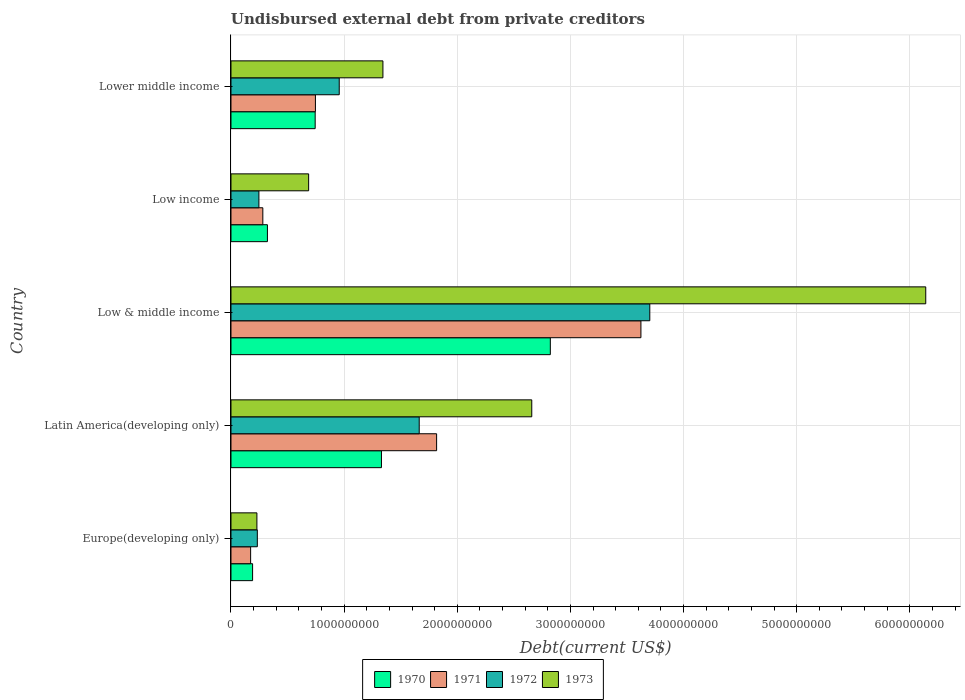How many groups of bars are there?
Offer a very short reply. 5. Are the number of bars on each tick of the Y-axis equal?
Offer a terse response. Yes. How many bars are there on the 1st tick from the bottom?
Your response must be concise. 4. What is the label of the 1st group of bars from the top?
Provide a short and direct response. Lower middle income. In how many cases, is the number of bars for a given country not equal to the number of legend labels?
Make the answer very short. 0. What is the total debt in 1971 in Latin America(developing only)?
Make the answer very short. 1.82e+09. Across all countries, what is the maximum total debt in 1973?
Your answer should be very brief. 6.14e+09. Across all countries, what is the minimum total debt in 1970?
Your answer should be compact. 1.91e+08. In which country was the total debt in 1970 minimum?
Make the answer very short. Europe(developing only). What is the total total debt in 1973 in the graph?
Your response must be concise. 1.11e+1. What is the difference between the total debt in 1972 in Low & middle income and that in Low income?
Keep it short and to the point. 3.45e+09. What is the difference between the total debt in 1972 in Latin America(developing only) and the total debt in 1973 in Low & middle income?
Your answer should be compact. -4.48e+09. What is the average total debt in 1973 per country?
Provide a succinct answer. 2.21e+09. What is the difference between the total debt in 1970 and total debt in 1973 in Latin America(developing only)?
Provide a short and direct response. -1.33e+09. What is the ratio of the total debt in 1971 in Latin America(developing only) to that in Lower middle income?
Offer a very short reply. 2.44. Is the total debt in 1972 in Europe(developing only) less than that in Low income?
Provide a short and direct response. Yes. Is the difference between the total debt in 1970 in Latin America(developing only) and Low & middle income greater than the difference between the total debt in 1973 in Latin America(developing only) and Low & middle income?
Offer a very short reply. Yes. What is the difference between the highest and the second highest total debt in 1970?
Provide a succinct answer. 1.49e+09. What is the difference between the highest and the lowest total debt in 1972?
Your answer should be compact. 3.47e+09. Is it the case that in every country, the sum of the total debt in 1971 and total debt in 1973 is greater than the sum of total debt in 1972 and total debt in 1970?
Offer a very short reply. No. What does the 2nd bar from the bottom in Low & middle income represents?
Ensure brevity in your answer.  1971. Is it the case that in every country, the sum of the total debt in 1970 and total debt in 1972 is greater than the total debt in 1971?
Ensure brevity in your answer.  Yes. Are all the bars in the graph horizontal?
Your response must be concise. Yes. What is the difference between two consecutive major ticks on the X-axis?
Your response must be concise. 1.00e+09. Are the values on the major ticks of X-axis written in scientific E-notation?
Offer a terse response. No. Does the graph contain grids?
Offer a terse response. Yes. Where does the legend appear in the graph?
Give a very brief answer. Bottom center. How are the legend labels stacked?
Provide a succinct answer. Horizontal. What is the title of the graph?
Provide a short and direct response. Undisbursed external debt from private creditors. Does "2007" appear as one of the legend labels in the graph?
Your response must be concise. No. What is the label or title of the X-axis?
Provide a short and direct response. Debt(current US$). What is the Debt(current US$) in 1970 in Europe(developing only)?
Your answer should be compact. 1.91e+08. What is the Debt(current US$) in 1971 in Europe(developing only)?
Provide a succinct answer. 1.74e+08. What is the Debt(current US$) of 1972 in Europe(developing only)?
Ensure brevity in your answer.  2.33e+08. What is the Debt(current US$) of 1973 in Europe(developing only)?
Your answer should be compact. 2.29e+08. What is the Debt(current US$) of 1970 in Latin America(developing only)?
Ensure brevity in your answer.  1.33e+09. What is the Debt(current US$) of 1971 in Latin America(developing only)?
Ensure brevity in your answer.  1.82e+09. What is the Debt(current US$) of 1972 in Latin America(developing only)?
Keep it short and to the point. 1.66e+09. What is the Debt(current US$) of 1973 in Latin America(developing only)?
Make the answer very short. 2.66e+09. What is the Debt(current US$) of 1970 in Low & middle income?
Provide a short and direct response. 2.82e+09. What is the Debt(current US$) of 1971 in Low & middle income?
Offer a terse response. 3.62e+09. What is the Debt(current US$) in 1972 in Low & middle income?
Provide a short and direct response. 3.70e+09. What is the Debt(current US$) in 1973 in Low & middle income?
Your answer should be compact. 6.14e+09. What is the Debt(current US$) in 1970 in Low income?
Provide a succinct answer. 3.22e+08. What is the Debt(current US$) in 1971 in Low income?
Offer a terse response. 2.82e+08. What is the Debt(current US$) of 1972 in Low income?
Provide a succinct answer. 2.47e+08. What is the Debt(current US$) of 1973 in Low income?
Make the answer very short. 6.86e+08. What is the Debt(current US$) in 1970 in Lower middle income?
Your answer should be very brief. 7.44e+08. What is the Debt(current US$) in 1971 in Lower middle income?
Your answer should be very brief. 7.46e+08. What is the Debt(current US$) of 1972 in Lower middle income?
Offer a terse response. 9.57e+08. What is the Debt(current US$) in 1973 in Lower middle income?
Make the answer very short. 1.34e+09. Across all countries, what is the maximum Debt(current US$) in 1970?
Give a very brief answer. 2.82e+09. Across all countries, what is the maximum Debt(current US$) in 1971?
Make the answer very short. 3.62e+09. Across all countries, what is the maximum Debt(current US$) in 1972?
Your answer should be very brief. 3.70e+09. Across all countries, what is the maximum Debt(current US$) in 1973?
Give a very brief answer. 6.14e+09. Across all countries, what is the minimum Debt(current US$) of 1970?
Your answer should be compact. 1.91e+08. Across all countries, what is the minimum Debt(current US$) of 1971?
Make the answer very short. 1.74e+08. Across all countries, what is the minimum Debt(current US$) in 1972?
Give a very brief answer. 2.33e+08. Across all countries, what is the minimum Debt(current US$) of 1973?
Give a very brief answer. 2.29e+08. What is the total Debt(current US$) in 1970 in the graph?
Give a very brief answer. 5.41e+09. What is the total Debt(current US$) of 1971 in the graph?
Your answer should be compact. 6.64e+09. What is the total Debt(current US$) of 1972 in the graph?
Your response must be concise. 6.80e+09. What is the total Debt(current US$) in 1973 in the graph?
Give a very brief answer. 1.11e+1. What is the difference between the Debt(current US$) of 1970 in Europe(developing only) and that in Latin America(developing only)?
Provide a short and direct response. -1.14e+09. What is the difference between the Debt(current US$) in 1971 in Europe(developing only) and that in Latin America(developing only)?
Provide a short and direct response. -1.64e+09. What is the difference between the Debt(current US$) in 1972 in Europe(developing only) and that in Latin America(developing only)?
Provide a short and direct response. -1.43e+09. What is the difference between the Debt(current US$) of 1973 in Europe(developing only) and that in Latin America(developing only)?
Offer a terse response. -2.43e+09. What is the difference between the Debt(current US$) of 1970 in Europe(developing only) and that in Low & middle income?
Make the answer very short. -2.63e+09. What is the difference between the Debt(current US$) in 1971 in Europe(developing only) and that in Low & middle income?
Give a very brief answer. -3.45e+09. What is the difference between the Debt(current US$) in 1972 in Europe(developing only) and that in Low & middle income?
Make the answer very short. -3.47e+09. What is the difference between the Debt(current US$) of 1973 in Europe(developing only) and that in Low & middle income?
Your response must be concise. -5.91e+09. What is the difference between the Debt(current US$) of 1970 in Europe(developing only) and that in Low income?
Make the answer very short. -1.31e+08. What is the difference between the Debt(current US$) in 1971 in Europe(developing only) and that in Low income?
Ensure brevity in your answer.  -1.08e+08. What is the difference between the Debt(current US$) in 1972 in Europe(developing only) and that in Low income?
Your response must be concise. -1.39e+07. What is the difference between the Debt(current US$) in 1973 in Europe(developing only) and that in Low income?
Your answer should be compact. -4.57e+08. What is the difference between the Debt(current US$) of 1970 in Europe(developing only) and that in Lower middle income?
Your answer should be compact. -5.53e+08. What is the difference between the Debt(current US$) in 1971 in Europe(developing only) and that in Lower middle income?
Offer a terse response. -5.73e+08. What is the difference between the Debt(current US$) in 1972 in Europe(developing only) and that in Lower middle income?
Ensure brevity in your answer.  -7.24e+08. What is the difference between the Debt(current US$) of 1973 in Europe(developing only) and that in Lower middle income?
Provide a short and direct response. -1.11e+09. What is the difference between the Debt(current US$) of 1970 in Latin America(developing only) and that in Low & middle income?
Make the answer very short. -1.49e+09. What is the difference between the Debt(current US$) of 1971 in Latin America(developing only) and that in Low & middle income?
Your answer should be compact. -1.81e+09. What is the difference between the Debt(current US$) of 1972 in Latin America(developing only) and that in Low & middle income?
Give a very brief answer. -2.04e+09. What is the difference between the Debt(current US$) of 1973 in Latin America(developing only) and that in Low & middle income?
Provide a short and direct response. -3.48e+09. What is the difference between the Debt(current US$) in 1970 in Latin America(developing only) and that in Low income?
Make the answer very short. 1.01e+09. What is the difference between the Debt(current US$) in 1971 in Latin America(developing only) and that in Low income?
Provide a short and direct response. 1.54e+09. What is the difference between the Debt(current US$) of 1972 in Latin America(developing only) and that in Low income?
Make the answer very short. 1.42e+09. What is the difference between the Debt(current US$) in 1973 in Latin America(developing only) and that in Low income?
Your answer should be compact. 1.97e+09. What is the difference between the Debt(current US$) in 1970 in Latin America(developing only) and that in Lower middle income?
Ensure brevity in your answer.  5.86e+08. What is the difference between the Debt(current US$) of 1971 in Latin America(developing only) and that in Lower middle income?
Provide a succinct answer. 1.07e+09. What is the difference between the Debt(current US$) of 1972 in Latin America(developing only) and that in Lower middle income?
Provide a succinct answer. 7.07e+08. What is the difference between the Debt(current US$) in 1973 in Latin America(developing only) and that in Lower middle income?
Provide a short and direct response. 1.32e+09. What is the difference between the Debt(current US$) of 1970 in Low & middle income and that in Low income?
Your answer should be very brief. 2.50e+09. What is the difference between the Debt(current US$) in 1971 in Low & middle income and that in Low income?
Offer a very short reply. 3.34e+09. What is the difference between the Debt(current US$) of 1972 in Low & middle income and that in Low income?
Offer a very short reply. 3.45e+09. What is the difference between the Debt(current US$) in 1973 in Low & middle income and that in Low income?
Provide a succinct answer. 5.45e+09. What is the difference between the Debt(current US$) of 1970 in Low & middle income and that in Lower middle income?
Offer a very short reply. 2.08e+09. What is the difference between the Debt(current US$) in 1971 in Low & middle income and that in Lower middle income?
Give a very brief answer. 2.88e+09. What is the difference between the Debt(current US$) in 1972 in Low & middle income and that in Lower middle income?
Provide a succinct answer. 2.74e+09. What is the difference between the Debt(current US$) in 1973 in Low & middle income and that in Lower middle income?
Your response must be concise. 4.80e+09. What is the difference between the Debt(current US$) of 1970 in Low income and that in Lower middle income?
Ensure brevity in your answer.  -4.22e+08. What is the difference between the Debt(current US$) of 1971 in Low income and that in Lower middle income?
Offer a very short reply. -4.65e+08. What is the difference between the Debt(current US$) of 1972 in Low income and that in Lower middle income?
Your answer should be very brief. -7.10e+08. What is the difference between the Debt(current US$) of 1973 in Low income and that in Lower middle income?
Provide a succinct answer. -6.56e+08. What is the difference between the Debt(current US$) in 1970 in Europe(developing only) and the Debt(current US$) in 1971 in Latin America(developing only)?
Your response must be concise. -1.63e+09. What is the difference between the Debt(current US$) of 1970 in Europe(developing only) and the Debt(current US$) of 1972 in Latin America(developing only)?
Ensure brevity in your answer.  -1.47e+09. What is the difference between the Debt(current US$) of 1970 in Europe(developing only) and the Debt(current US$) of 1973 in Latin America(developing only)?
Ensure brevity in your answer.  -2.47e+09. What is the difference between the Debt(current US$) of 1971 in Europe(developing only) and the Debt(current US$) of 1972 in Latin America(developing only)?
Provide a succinct answer. -1.49e+09. What is the difference between the Debt(current US$) in 1971 in Europe(developing only) and the Debt(current US$) in 1973 in Latin America(developing only)?
Offer a very short reply. -2.48e+09. What is the difference between the Debt(current US$) in 1972 in Europe(developing only) and the Debt(current US$) in 1973 in Latin America(developing only)?
Offer a very short reply. -2.43e+09. What is the difference between the Debt(current US$) in 1970 in Europe(developing only) and the Debt(current US$) in 1971 in Low & middle income?
Ensure brevity in your answer.  -3.43e+09. What is the difference between the Debt(current US$) of 1970 in Europe(developing only) and the Debt(current US$) of 1972 in Low & middle income?
Provide a short and direct response. -3.51e+09. What is the difference between the Debt(current US$) of 1970 in Europe(developing only) and the Debt(current US$) of 1973 in Low & middle income?
Your response must be concise. -5.95e+09. What is the difference between the Debt(current US$) in 1971 in Europe(developing only) and the Debt(current US$) in 1972 in Low & middle income?
Provide a succinct answer. -3.53e+09. What is the difference between the Debt(current US$) of 1971 in Europe(developing only) and the Debt(current US$) of 1973 in Low & middle income?
Your answer should be compact. -5.97e+09. What is the difference between the Debt(current US$) of 1972 in Europe(developing only) and the Debt(current US$) of 1973 in Low & middle income?
Your response must be concise. -5.91e+09. What is the difference between the Debt(current US$) of 1970 in Europe(developing only) and the Debt(current US$) of 1971 in Low income?
Offer a terse response. -9.05e+07. What is the difference between the Debt(current US$) in 1970 in Europe(developing only) and the Debt(current US$) in 1972 in Low income?
Give a very brief answer. -5.58e+07. What is the difference between the Debt(current US$) in 1970 in Europe(developing only) and the Debt(current US$) in 1973 in Low income?
Make the answer very short. -4.95e+08. What is the difference between the Debt(current US$) in 1971 in Europe(developing only) and the Debt(current US$) in 1972 in Low income?
Your response must be concise. -7.31e+07. What is the difference between the Debt(current US$) of 1971 in Europe(developing only) and the Debt(current US$) of 1973 in Low income?
Give a very brief answer. -5.13e+08. What is the difference between the Debt(current US$) of 1972 in Europe(developing only) and the Debt(current US$) of 1973 in Low income?
Ensure brevity in your answer.  -4.54e+08. What is the difference between the Debt(current US$) of 1970 in Europe(developing only) and the Debt(current US$) of 1971 in Lower middle income?
Keep it short and to the point. -5.55e+08. What is the difference between the Debt(current US$) in 1970 in Europe(developing only) and the Debt(current US$) in 1972 in Lower middle income?
Keep it short and to the point. -7.66e+08. What is the difference between the Debt(current US$) in 1970 in Europe(developing only) and the Debt(current US$) in 1973 in Lower middle income?
Provide a succinct answer. -1.15e+09. What is the difference between the Debt(current US$) of 1971 in Europe(developing only) and the Debt(current US$) of 1972 in Lower middle income?
Provide a short and direct response. -7.83e+08. What is the difference between the Debt(current US$) of 1971 in Europe(developing only) and the Debt(current US$) of 1973 in Lower middle income?
Keep it short and to the point. -1.17e+09. What is the difference between the Debt(current US$) of 1972 in Europe(developing only) and the Debt(current US$) of 1973 in Lower middle income?
Give a very brief answer. -1.11e+09. What is the difference between the Debt(current US$) in 1970 in Latin America(developing only) and the Debt(current US$) in 1971 in Low & middle income?
Provide a succinct answer. -2.29e+09. What is the difference between the Debt(current US$) of 1970 in Latin America(developing only) and the Debt(current US$) of 1972 in Low & middle income?
Your response must be concise. -2.37e+09. What is the difference between the Debt(current US$) in 1970 in Latin America(developing only) and the Debt(current US$) in 1973 in Low & middle income?
Your answer should be compact. -4.81e+09. What is the difference between the Debt(current US$) of 1971 in Latin America(developing only) and the Debt(current US$) of 1972 in Low & middle income?
Give a very brief answer. -1.88e+09. What is the difference between the Debt(current US$) in 1971 in Latin America(developing only) and the Debt(current US$) in 1973 in Low & middle income?
Provide a short and direct response. -4.32e+09. What is the difference between the Debt(current US$) of 1972 in Latin America(developing only) and the Debt(current US$) of 1973 in Low & middle income?
Offer a terse response. -4.48e+09. What is the difference between the Debt(current US$) in 1970 in Latin America(developing only) and the Debt(current US$) in 1971 in Low income?
Your answer should be compact. 1.05e+09. What is the difference between the Debt(current US$) of 1970 in Latin America(developing only) and the Debt(current US$) of 1972 in Low income?
Provide a short and direct response. 1.08e+09. What is the difference between the Debt(current US$) in 1970 in Latin America(developing only) and the Debt(current US$) in 1973 in Low income?
Provide a succinct answer. 6.43e+08. What is the difference between the Debt(current US$) of 1971 in Latin America(developing only) and the Debt(current US$) of 1972 in Low income?
Offer a terse response. 1.57e+09. What is the difference between the Debt(current US$) in 1971 in Latin America(developing only) and the Debt(current US$) in 1973 in Low income?
Give a very brief answer. 1.13e+09. What is the difference between the Debt(current US$) of 1972 in Latin America(developing only) and the Debt(current US$) of 1973 in Low income?
Provide a succinct answer. 9.77e+08. What is the difference between the Debt(current US$) in 1970 in Latin America(developing only) and the Debt(current US$) in 1971 in Lower middle income?
Ensure brevity in your answer.  5.84e+08. What is the difference between the Debt(current US$) of 1970 in Latin America(developing only) and the Debt(current US$) of 1972 in Lower middle income?
Your answer should be very brief. 3.73e+08. What is the difference between the Debt(current US$) of 1970 in Latin America(developing only) and the Debt(current US$) of 1973 in Lower middle income?
Give a very brief answer. -1.29e+07. What is the difference between the Debt(current US$) of 1971 in Latin America(developing only) and the Debt(current US$) of 1972 in Lower middle income?
Provide a short and direct response. 8.61e+08. What is the difference between the Debt(current US$) in 1971 in Latin America(developing only) and the Debt(current US$) in 1973 in Lower middle income?
Provide a short and direct response. 4.75e+08. What is the difference between the Debt(current US$) in 1972 in Latin America(developing only) and the Debt(current US$) in 1973 in Lower middle income?
Your answer should be compact. 3.21e+08. What is the difference between the Debt(current US$) in 1970 in Low & middle income and the Debt(current US$) in 1971 in Low income?
Your answer should be very brief. 2.54e+09. What is the difference between the Debt(current US$) in 1970 in Low & middle income and the Debt(current US$) in 1972 in Low income?
Your answer should be very brief. 2.58e+09. What is the difference between the Debt(current US$) in 1970 in Low & middle income and the Debt(current US$) in 1973 in Low income?
Give a very brief answer. 2.14e+09. What is the difference between the Debt(current US$) in 1971 in Low & middle income and the Debt(current US$) in 1972 in Low income?
Your response must be concise. 3.38e+09. What is the difference between the Debt(current US$) in 1971 in Low & middle income and the Debt(current US$) in 1973 in Low income?
Your response must be concise. 2.94e+09. What is the difference between the Debt(current US$) of 1972 in Low & middle income and the Debt(current US$) of 1973 in Low income?
Provide a succinct answer. 3.02e+09. What is the difference between the Debt(current US$) of 1970 in Low & middle income and the Debt(current US$) of 1971 in Lower middle income?
Your response must be concise. 2.08e+09. What is the difference between the Debt(current US$) in 1970 in Low & middle income and the Debt(current US$) in 1972 in Lower middle income?
Provide a short and direct response. 1.87e+09. What is the difference between the Debt(current US$) of 1970 in Low & middle income and the Debt(current US$) of 1973 in Lower middle income?
Ensure brevity in your answer.  1.48e+09. What is the difference between the Debt(current US$) in 1971 in Low & middle income and the Debt(current US$) in 1972 in Lower middle income?
Keep it short and to the point. 2.67e+09. What is the difference between the Debt(current US$) in 1971 in Low & middle income and the Debt(current US$) in 1973 in Lower middle income?
Provide a succinct answer. 2.28e+09. What is the difference between the Debt(current US$) of 1972 in Low & middle income and the Debt(current US$) of 1973 in Lower middle income?
Your answer should be compact. 2.36e+09. What is the difference between the Debt(current US$) in 1970 in Low income and the Debt(current US$) in 1971 in Lower middle income?
Provide a short and direct response. -4.24e+08. What is the difference between the Debt(current US$) in 1970 in Low income and the Debt(current US$) in 1972 in Lower middle income?
Your answer should be very brief. -6.35e+08. What is the difference between the Debt(current US$) of 1970 in Low income and the Debt(current US$) of 1973 in Lower middle income?
Ensure brevity in your answer.  -1.02e+09. What is the difference between the Debt(current US$) of 1971 in Low income and the Debt(current US$) of 1972 in Lower middle income?
Provide a short and direct response. -6.75e+08. What is the difference between the Debt(current US$) of 1971 in Low income and the Debt(current US$) of 1973 in Lower middle income?
Your response must be concise. -1.06e+09. What is the difference between the Debt(current US$) of 1972 in Low income and the Debt(current US$) of 1973 in Lower middle income?
Make the answer very short. -1.10e+09. What is the average Debt(current US$) in 1970 per country?
Provide a succinct answer. 1.08e+09. What is the average Debt(current US$) in 1971 per country?
Provide a short and direct response. 1.33e+09. What is the average Debt(current US$) of 1972 per country?
Provide a succinct answer. 1.36e+09. What is the average Debt(current US$) in 1973 per country?
Your answer should be compact. 2.21e+09. What is the difference between the Debt(current US$) in 1970 and Debt(current US$) in 1971 in Europe(developing only)?
Make the answer very short. 1.74e+07. What is the difference between the Debt(current US$) of 1970 and Debt(current US$) of 1972 in Europe(developing only)?
Offer a terse response. -4.19e+07. What is the difference between the Debt(current US$) of 1970 and Debt(current US$) of 1973 in Europe(developing only)?
Your response must be concise. -3.81e+07. What is the difference between the Debt(current US$) of 1971 and Debt(current US$) of 1972 in Europe(developing only)?
Offer a terse response. -5.92e+07. What is the difference between the Debt(current US$) of 1971 and Debt(current US$) of 1973 in Europe(developing only)?
Offer a terse response. -5.55e+07. What is the difference between the Debt(current US$) in 1972 and Debt(current US$) in 1973 in Europe(developing only)?
Your response must be concise. 3.73e+06. What is the difference between the Debt(current US$) of 1970 and Debt(current US$) of 1971 in Latin America(developing only)?
Provide a succinct answer. -4.88e+08. What is the difference between the Debt(current US$) in 1970 and Debt(current US$) in 1972 in Latin America(developing only)?
Provide a succinct answer. -3.34e+08. What is the difference between the Debt(current US$) in 1970 and Debt(current US$) in 1973 in Latin America(developing only)?
Make the answer very short. -1.33e+09. What is the difference between the Debt(current US$) of 1971 and Debt(current US$) of 1972 in Latin America(developing only)?
Make the answer very short. 1.54e+08. What is the difference between the Debt(current US$) of 1971 and Debt(current US$) of 1973 in Latin America(developing only)?
Offer a very short reply. -8.41e+08. What is the difference between the Debt(current US$) of 1972 and Debt(current US$) of 1973 in Latin America(developing only)?
Give a very brief answer. -9.95e+08. What is the difference between the Debt(current US$) of 1970 and Debt(current US$) of 1971 in Low & middle income?
Your answer should be compact. -8.01e+08. What is the difference between the Debt(current US$) in 1970 and Debt(current US$) in 1972 in Low & middle income?
Give a very brief answer. -8.79e+08. What is the difference between the Debt(current US$) in 1970 and Debt(current US$) in 1973 in Low & middle income?
Ensure brevity in your answer.  -3.32e+09. What is the difference between the Debt(current US$) of 1971 and Debt(current US$) of 1972 in Low & middle income?
Make the answer very short. -7.84e+07. What is the difference between the Debt(current US$) of 1971 and Debt(current US$) of 1973 in Low & middle income?
Provide a short and direct response. -2.52e+09. What is the difference between the Debt(current US$) in 1972 and Debt(current US$) in 1973 in Low & middle income?
Your response must be concise. -2.44e+09. What is the difference between the Debt(current US$) in 1970 and Debt(current US$) in 1971 in Low income?
Provide a succinct answer. 4.06e+07. What is the difference between the Debt(current US$) in 1970 and Debt(current US$) in 1972 in Low income?
Keep it short and to the point. 7.53e+07. What is the difference between the Debt(current US$) in 1970 and Debt(current US$) in 1973 in Low income?
Make the answer very short. -3.64e+08. What is the difference between the Debt(current US$) of 1971 and Debt(current US$) of 1972 in Low income?
Provide a succinct answer. 3.47e+07. What is the difference between the Debt(current US$) of 1971 and Debt(current US$) of 1973 in Low income?
Your answer should be compact. -4.05e+08. What is the difference between the Debt(current US$) of 1972 and Debt(current US$) of 1973 in Low income?
Ensure brevity in your answer.  -4.40e+08. What is the difference between the Debt(current US$) in 1970 and Debt(current US$) in 1971 in Lower middle income?
Offer a very short reply. -2.10e+06. What is the difference between the Debt(current US$) in 1970 and Debt(current US$) in 1972 in Lower middle income?
Provide a succinct answer. -2.13e+08. What is the difference between the Debt(current US$) of 1970 and Debt(current US$) of 1973 in Lower middle income?
Your answer should be very brief. -5.99e+08. What is the difference between the Debt(current US$) of 1971 and Debt(current US$) of 1972 in Lower middle income?
Offer a very short reply. -2.11e+08. What is the difference between the Debt(current US$) of 1971 and Debt(current US$) of 1973 in Lower middle income?
Provide a short and direct response. -5.97e+08. What is the difference between the Debt(current US$) in 1972 and Debt(current US$) in 1973 in Lower middle income?
Give a very brief answer. -3.86e+08. What is the ratio of the Debt(current US$) of 1970 in Europe(developing only) to that in Latin America(developing only)?
Your response must be concise. 0.14. What is the ratio of the Debt(current US$) in 1971 in Europe(developing only) to that in Latin America(developing only)?
Give a very brief answer. 0.1. What is the ratio of the Debt(current US$) of 1972 in Europe(developing only) to that in Latin America(developing only)?
Give a very brief answer. 0.14. What is the ratio of the Debt(current US$) in 1973 in Europe(developing only) to that in Latin America(developing only)?
Ensure brevity in your answer.  0.09. What is the ratio of the Debt(current US$) of 1970 in Europe(developing only) to that in Low & middle income?
Your answer should be compact. 0.07. What is the ratio of the Debt(current US$) of 1971 in Europe(developing only) to that in Low & middle income?
Your answer should be compact. 0.05. What is the ratio of the Debt(current US$) in 1972 in Europe(developing only) to that in Low & middle income?
Provide a succinct answer. 0.06. What is the ratio of the Debt(current US$) in 1973 in Europe(developing only) to that in Low & middle income?
Offer a terse response. 0.04. What is the ratio of the Debt(current US$) of 1970 in Europe(developing only) to that in Low income?
Your answer should be very brief. 0.59. What is the ratio of the Debt(current US$) of 1971 in Europe(developing only) to that in Low income?
Your response must be concise. 0.62. What is the ratio of the Debt(current US$) of 1972 in Europe(developing only) to that in Low income?
Give a very brief answer. 0.94. What is the ratio of the Debt(current US$) in 1973 in Europe(developing only) to that in Low income?
Your answer should be compact. 0.33. What is the ratio of the Debt(current US$) of 1970 in Europe(developing only) to that in Lower middle income?
Make the answer very short. 0.26. What is the ratio of the Debt(current US$) of 1971 in Europe(developing only) to that in Lower middle income?
Ensure brevity in your answer.  0.23. What is the ratio of the Debt(current US$) in 1972 in Europe(developing only) to that in Lower middle income?
Your answer should be very brief. 0.24. What is the ratio of the Debt(current US$) of 1973 in Europe(developing only) to that in Lower middle income?
Make the answer very short. 0.17. What is the ratio of the Debt(current US$) in 1970 in Latin America(developing only) to that in Low & middle income?
Ensure brevity in your answer.  0.47. What is the ratio of the Debt(current US$) of 1971 in Latin America(developing only) to that in Low & middle income?
Give a very brief answer. 0.5. What is the ratio of the Debt(current US$) of 1972 in Latin America(developing only) to that in Low & middle income?
Ensure brevity in your answer.  0.45. What is the ratio of the Debt(current US$) of 1973 in Latin America(developing only) to that in Low & middle income?
Offer a very short reply. 0.43. What is the ratio of the Debt(current US$) of 1970 in Latin America(developing only) to that in Low income?
Make the answer very short. 4.13. What is the ratio of the Debt(current US$) of 1971 in Latin America(developing only) to that in Low income?
Make the answer very short. 6.46. What is the ratio of the Debt(current US$) in 1972 in Latin America(developing only) to that in Low income?
Provide a succinct answer. 6.74. What is the ratio of the Debt(current US$) in 1973 in Latin America(developing only) to that in Low income?
Your answer should be compact. 3.87. What is the ratio of the Debt(current US$) in 1970 in Latin America(developing only) to that in Lower middle income?
Provide a short and direct response. 1.79. What is the ratio of the Debt(current US$) in 1971 in Latin America(developing only) to that in Lower middle income?
Ensure brevity in your answer.  2.44. What is the ratio of the Debt(current US$) of 1972 in Latin America(developing only) to that in Lower middle income?
Make the answer very short. 1.74. What is the ratio of the Debt(current US$) of 1973 in Latin America(developing only) to that in Lower middle income?
Make the answer very short. 1.98. What is the ratio of the Debt(current US$) in 1970 in Low & middle income to that in Low income?
Your answer should be very brief. 8.76. What is the ratio of the Debt(current US$) of 1971 in Low & middle income to that in Low income?
Give a very brief answer. 12.87. What is the ratio of the Debt(current US$) in 1972 in Low & middle income to that in Low income?
Offer a terse response. 15. What is the ratio of the Debt(current US$) in 1973 in Low & middle income to that in Low income?
Ensure brevity in your answer.  8.95. What is the ratio of the Debt(current US$) of 1970 in Low & middle income to that in Lower middle income?
Offer a terse response. 3.79. What is the ratio of the Debt(current US$) of 1971 in Low & middle income to that in Lower middle income?
Offer a very short reply. 4.86. What is the ratio of the Debt(current US$) in 1972 in Low & middle income to that in Lower middle income?
Ensure brevity in your answer.  3.87. What is the ratio of the Debt(current US$) of 1973 in Low & middle income to that in Lower middle income?
Give a very brief answer. 4.57. What is the ratio of the Debt(current US$) in 1970 in Low income to that in Lower middle income?
Provide a short and direct response. 0.43. What is the ratio of the Debt(current US$) in 1971 in Low income to that in Lower middle income?
Give a very brief answer. 0.38. What is the ratio of the Debt(current US$) of 1972 in Low income to that in Lower middle income?
Your answer should be compact. 0.26. What is the ratio of the Debt(current US$) of 1973 in Low income to that in Lower middle income?
Keep it short and to the point. 0.51. What is the difference between the highest and the second highest Debt(current US$) in 1970?
Ensure brevity in your answer.  1.49e+09. What is the difference between the highest and the second highest Debt(current US$) in 1971?
Keep it short and to the point. 1.81e+09. What is the difference between the highest and the second highest Debt(current US$) in 1972?
Make the answer very short. 2.04e+09. What is the difference between the highest and the second highest Debt(current US$) in 1973?
Offer a very short reply. 3.48e+09. What is the difference between the highest and the lowest Debt(current US$) in 1970?
Your answer should be very brief. 2.63e+09. What is the difference between the highest and the lowest Debt(current US$) in 1971?
Your response must be concise. 3.45e+09. What is the difference between the highest and the lowest Debt(current US$) of 1972?
Provide a succinct answer. 3.47e+09. What is the difference between the highest and the lowest Debt(current US$) of 1973?
Your answer should be compact. 5.91e+09. 